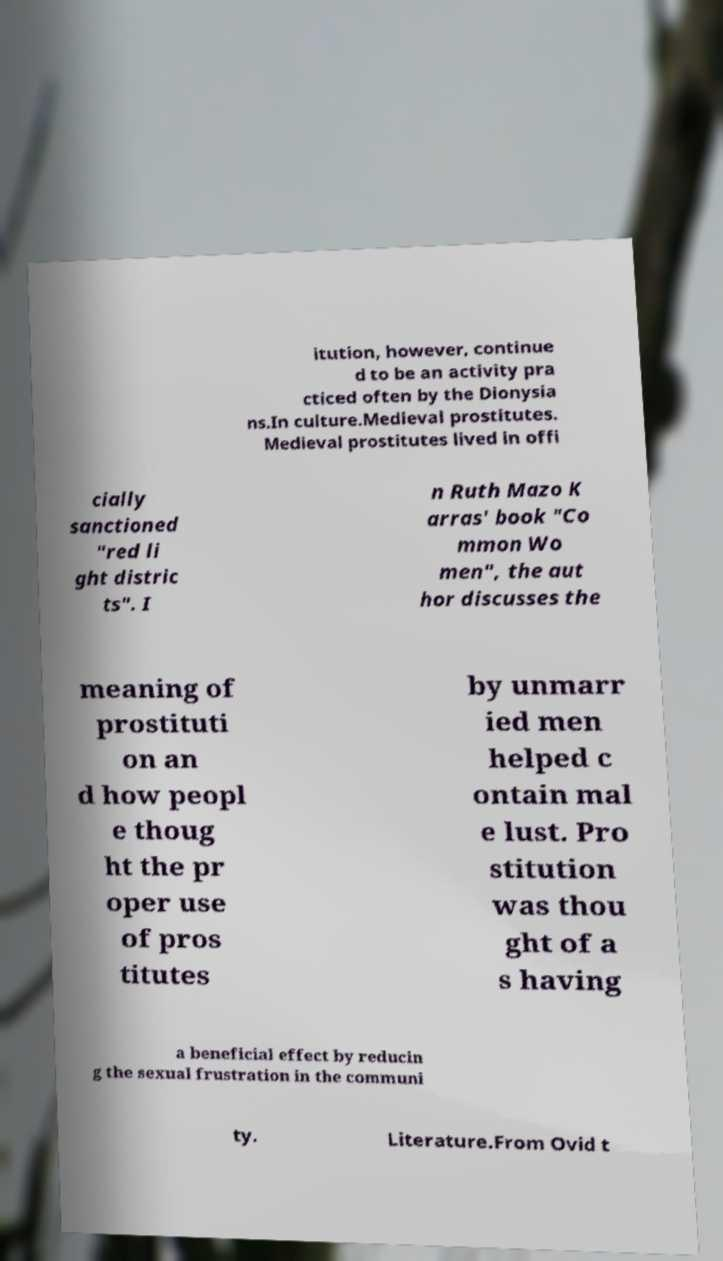Could you extract and type out the text from this image? itution, however, continue d to be an activity pra cticed often by the Dionysia ns.In culture.Medieval prostitutes. Medieval prostitutes lived in offi cially sanctioned "red li ght distric ts". I n Ruth Mazo K arras' book "Co mmon Wo men", the aut hor discusses the meaning of prostituti on an d how peopl e thoug ht the pr oper use of pros titutes by unmarr ied men helped c ontain mal e lust. Pro stitution was thou ght of a s having a beneficial effect by reducin g the sexual frustration in the communi ty. Literature.From Ovid t 